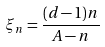<formula> <loc_0><loc_0><loc_500><loc_500>\xi _ { n } = \frac { ( d - 1 ) n } { A - n }</formula> 